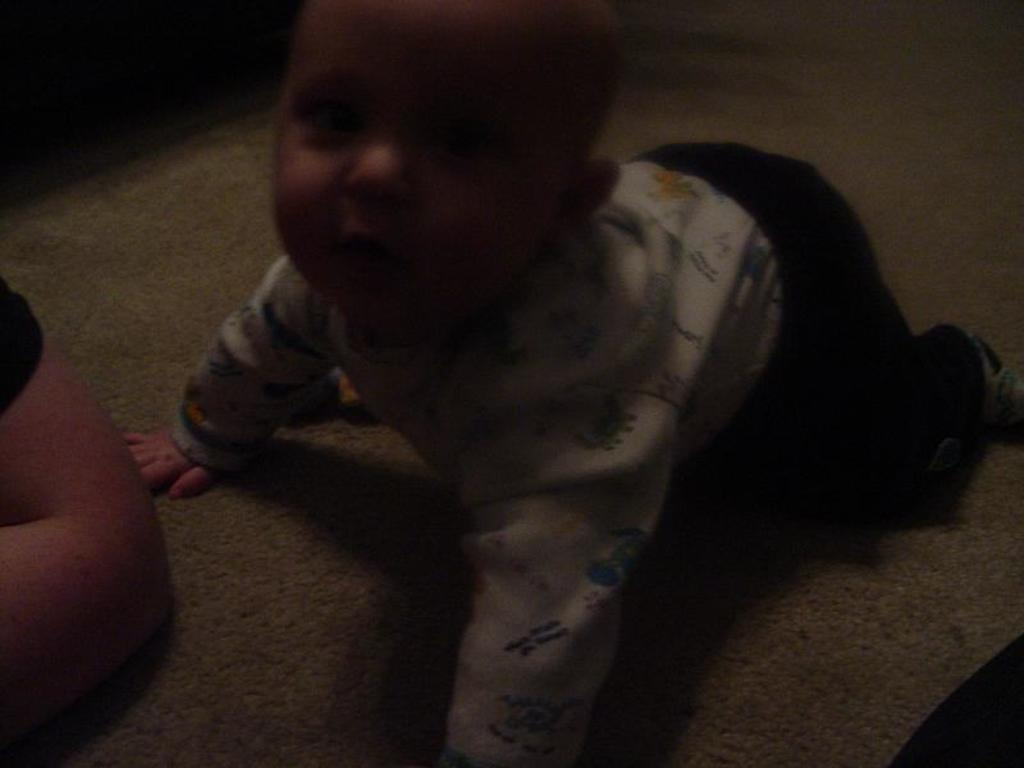What is the main subject of the image? There is a baby boy in the image. Where is the baby boy located? The baby boy is on the floor. Can you describe anything else visible in the image? There appears to be a person's hand on the left side of the image. What type of produce is being held by the baby boy in the image? There is no produce visible in the image; the baby boy is not holding anything. Can you tell me the color of the grape that the baby boy is eating in the image? There is no grape present in the image, and the baby boy is not eating anything. 